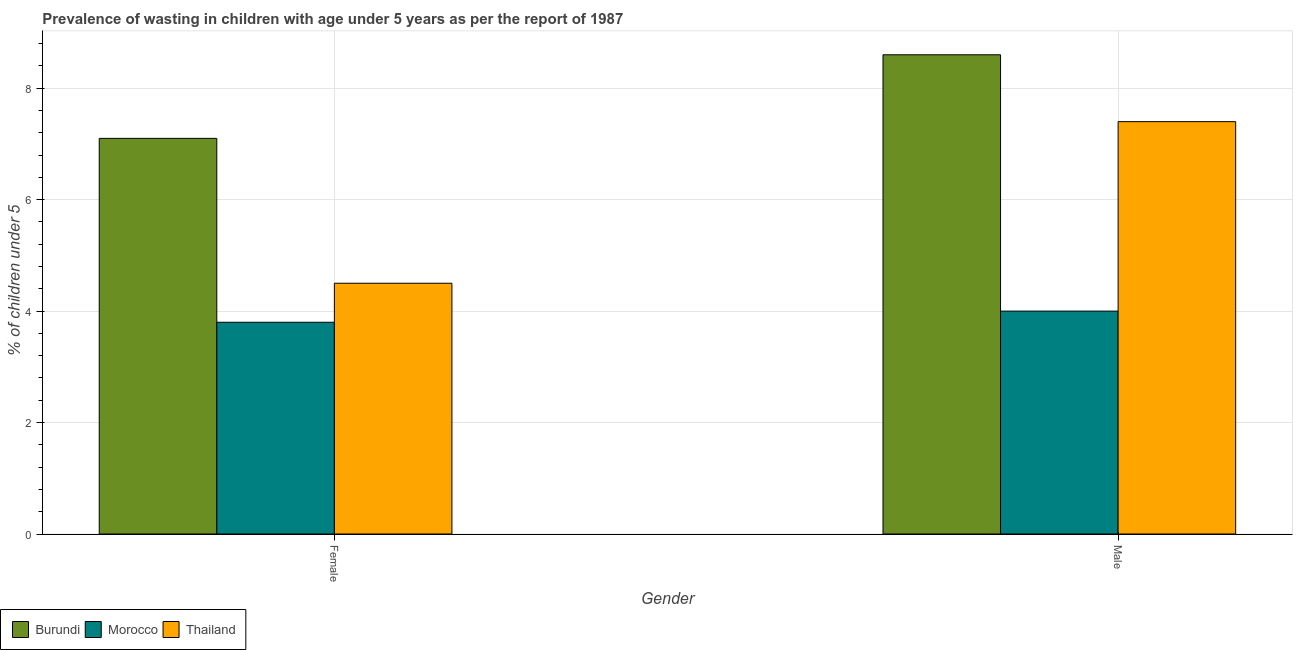How many different coloured bars are there?
Offer a terse response. 3. How many groups of bars are there?
Make the answer very short. 2. Are the number of bars on each tick of the X-axis equal?
Your answer should be very brief. Yes. How many bars are there on the 1st tick from the left?
Keep it short and to the point. 3. What is the label of the 2nd group of bars from the left?
Your answer should be compact. Male. What is the percentage of undernourished female children in Thailand?
Offer a very short reply. 4.5. Across all countries, what is the maximum percentage of undernourished female children?
Ensure brevity in your answer.  7.1. Across all countries, what is the minimum percentage of undernourished male children?
Keep it short and to the point. 4. In which country was the percentage of undernourished female children maximum?
Your response must be concise. Burundi. In which country was the percentage of undernourished male children minimum?
Provide a succinct answer. Morocco. What is the total percentage of undernourished female children in the graph?
Your answer should be compact. 15.4. What is the difference between the percentage of undernourished female children in Burundi and that in Morocco?
Your response must be concise. 3.3. What is the average percentage of undernourished male children per country?
Ensure brevity in your answer.  6.67. What is the difference between the percentage of undernourished female children and percentage of undernourished male children in Thailand?
Your answer should be compact. -2.9. What is the ratio of the percentage of undernourished female children in Thailand to that in Morocco?
Provide a succinct answer. 1.18. Is the percentage of undernourished male children in Burundi less than that in Morocco?
Give a very brief answer. No. What does the 2nd bar from the left in Male represents?
Offer a terse response. Morocco. What does the 1st bar from the right in Female represents?
Offer a terse response. Thailand. How many bars are there?
Provide a succinct answer. 6. Are all the bars in the graph horizontal?
Give a very brief answer. No. How many countries are there in the graph?
Make the answer very short. 3. Are the values on the major ticks of Y-axis written in scientific E-notation?
Provide a short and direct response. No. Does the graph contain any zero values?
Your answer should be compact. No. Does the graph contain grids?
Provide a short and direct response. Yes. Where does the legend appear in the graph?
Provide a succinct answer. Bottom left. How are the legend labels stacked?
Ensure brevity in your answer.  Horizontal. What is the title of the graph?
Make the answer very short. Prevalence of wasting in children with age under 5 years as per the report of 1987. Does "Arab World" appear as one of the legend labels in the graph?
Offer a very short reply. No. What is the label or title of the Y-axis?
Provide a short and direct response.  % of children under 5. What is the  % of children under 5 of Burundi in Female?
Provide a short and direct response. 7.1. What is the  % of children under 5 of Morocco in Female?
Your answer should be very brief. 3.8. What is the  % of children under 5 of Burundi in Male?
Ensure brevity in your answer.  8.6. What is the  % of children under 5 of Morocco in Male?
Provide a succinct answer. 4. What is the  % of children under 5 of Thailand in Male?
Ensure brevity in your answer.  7.4. Across all Gender, what is the maximum  % of children under 5 of Burundi?
Keep it short and to the point. 8.6. Across all Gender, what is the maximum  % of children under 5 of Thailand?
Your response must be concise. 7.4. Across all Gender, what is the minimum  % of children under 5 of Burundi?
Your response must be concise. 7.1. Across all Gender, what is the minimum  % of children under 5 of Morocco?
Your answer should be compact. 3.8. Across all Gender, what is the minimum  % of children under 5 in Thailand?
Ensure brevity in your answer.  4.5. What is the total  % of children under 5 in Burundi in the graph?
Ensure brevity in your answer.  15.7. What is the total  % of children under 5 of Morocco in the graph?
Provide a succinct answer. 7.8. What is the difference between the  % of children under 5 in Thailand in Female and that in Male?
Make the answer very short. -2.9. What is the difference between the  % of children under 5 of Morocco in Female and the  % of children under 5 of Thailand in Male?
Ensure brevity in your answer.  -3.6. What is the average  % of children under 5 of Burundi per Gender?
Your answer should be very brief. 7.85. What is the average  % of children under 5 of Thailand per Gender?
Your response must be concise. 5.95. What is the difference between the  % of children under 5 in Burundi and  % of children under 5 in Thailand in Female?
Your answer should be compact. 2.6. What is the difference between the  % of children under 5 in Morocco and  % of children under 5 in Thailand in Female?
Provide a short and direct response. -0.7. What is the difference between the  % of children under 5 in Burundi and  % of children under 5 in Morocco in Male?
Your response must be concise. 4.6. What is the difference between the  % of children under 5 in Morocco and  % of children under 5 in Thailand in Male?
Your response must be concise. -3.4. What is the ratio of the  % of children under 5 of Burundi in Female to that in Male?
Your answer should be compact. 0.83. What is the ratio of the  % of children under 5 in Morocco in Female to that in Male?
Provide a short and direct response. 0.95. What is the ratio of the  % of children under 5 of Thailand in Female to that in Male?
Provide a succinct answer. 0.61. What is the difference between the highest and the second highest  % of children under 5 of Burundi?
Your answer should be compact. 1.5. What is the difference between the highest and the second highest  % of children under 5 in Morocco?
Offer a very short reply. 0.2. What is the difference between the highest and the lowest  % of children under 5 in Burundi?
Make the answer very short. 1.5. 